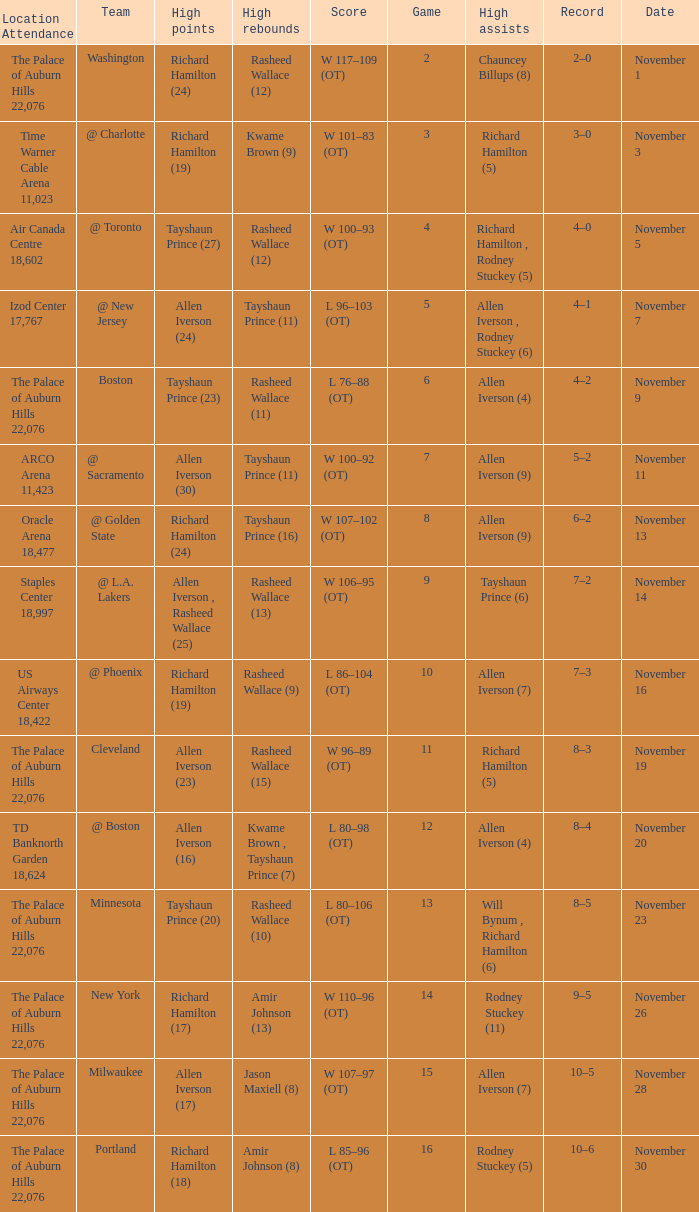What is High Points, when Game is "5"? Allen Iverson (24). 